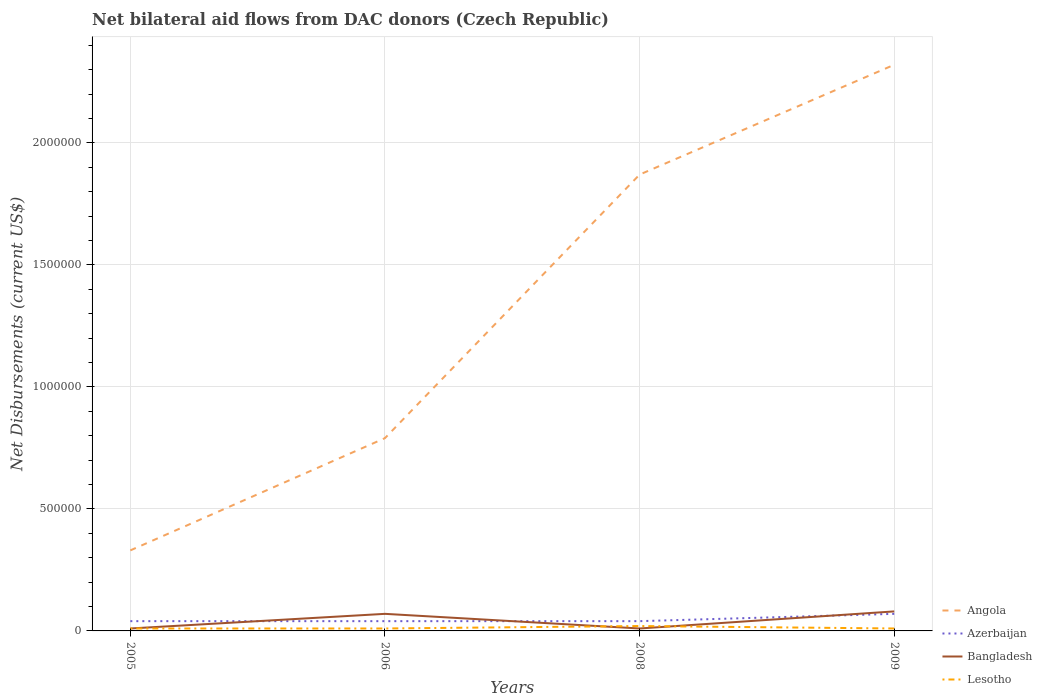How many different coloured lines are there?
Offer a very short reply. 4. Is the number of lines equal to the number of legend labels?
Make the answer very short. Yes. Across all years, what is the maximum net bilateral aid flows in Lesotho?
Your response must be concise. 10000. What is the total net bilateral aid flows in Azerbaijan in the graph?
Make the answer very short. -3.00e+04. What is the difference between the highest and the second highest net bilateral aid flows in Bangladesh?
Your answer should be compact. 7.00e+04. What is the difference between the highest and the lowest net bilateral aid flows in Lesotho?
Your answer should be compact. 1. How many years are there in the graph?
Offer a very short reply. 4. What is the difference between two consecutive major ticks on the Y-axis?
Offer a terse response. 5.00e+05. Are the values on the major ticks of Y-axis written in scientific E-notation?
Make the answer very short. No. Does the graph contain any zero values?
Ensure brevity in your answer.  No. How many legend labels are there?
Provide a succinct answer. 4. How are the legend labels stacked?
Ensure brevity in your answer.  Vertical. What is the title of the graph?
Ensure brevity in your answer.  Net bilateral aid flows from DAC donors (Czech Republic). Does "Channel Islands" appear as one of the legend labels in the graph?
Your answer should be very brief. No. What is the label or title of the Y-axis?
Give a very brief answer. Net Disbursements (current US$). What is the Net Disbursements (current US$) in Angola in 2005?
Make the answer very short. 3.30e+05. What is the Net Disbursements (current US$) in Azerbaijan in 2005?
Your response must be concise. 4.00e+04. What is the Net Disbursements (current US$) of Angola in 2006?
Provide a succinct answer. 7.90e+05. What is the Net Disbursements (current US$) in Lesotho in 2006?
Give a very brief answer. 10000. What is the Net Disbursements (current US$) in Angola in 2008?
Provide a short and direct response. 1.87e+06. What is the Net Disbursements (current US$) of Azerbaijan in 2008?
Your response must be concise. 4.00e+04. What is the Net Disbursements (current US$) of Bangladesh in 2008?
Provide a short and direct response. 10000. What is the Net Disbursements (current US$) in Lesotho in 2008?
Your answer should be compact. 2.00e+04. What is the Net Disbursements (current US$) in Angola in 2009?
Provide a succinct answer. 2.32e+06. What is the Net Disbursements (current US$) in Bangladesh in 2009?
Keep it short and to the point. 8.00e+04. What is the Net Disbursements (current US$) in Lesotho in 2009?
Make the answer very short. 10000. Across all years, what is the maximum Net Disbursements (current US$) of Angola?
Provide a short and direct response. 2.32e+06. Across all years, what is the maximum Net Disbursements (current US$) in Azerbaijan?
Provide a succinct answer. 7.00e+04. Across all years, what is the minimum Net Disbursements (current US$) of Angola?
Your answer should be very brief. 3.30e+05. Across all years, what is the minimum Net Disbursements (current US$) of Bangladesh?
Your answer should be very brief. 10000. Across all years, what is the minimum Net Disbursements (current US$) in Lesotho?
Offer a terse response. 10000. What is the total Net Disbursements (current US$) of Angola in the graph?
Keep it short and to the point. 5.31e+06. What is the difference between the Net Disbursements (current US$) of Angola in 2005 and that in 2006?
Ensure brevity in your answer.  -4.60e+05. What is the difference between the Net Disbursements (current US$) in Bangladesh in 2005 and that in 2006?
Your answer should be compact. -6.00e+04. What is the difference between the Net Disbursements (current US$) in Angola in 2005 and that in 2008?
Make the answer very short. -1.54e+06. What is the difference between the Net Disbursements (current US$) of Azerbaijan in 2005 and that in 2008?
Your response must be concise. 0. What is the difference between the Net Disbursements (current US$) of Bangladesh in 2005 and that in 2008?
Provide a succinct answer. 0. What is the difference between the Net Disbursements (current US$) in Lesotho in 2005 and that in 2008?
Your answer should be very brief. -10000. What is the difference between the Net Disbursements (current US$) in Angola in 2005 and that in 2009?
Offer a very short reply. -1.99e+06. What is the difference between the Net Disbursements (current US$) in Angola in 2006 and that in 2008?
Your answer should be very brief. -1.08e+06. What is the difference between the Net Disbursements (current US$) of Lesotho in 2006 and that in 2008?
Ensure brevity in your answer.  -10000. What is the difference between the Net Disbursements (current US$) in Angola in 2006 and that in 2009?
Your answer should be compact. -1.53e+06. What is the difference between the Net Disbursements (current US$) in Azerbaijan in 2006 and that in 2009?
Offer a very short reply. -3.00e+04. What is the difference between the Net Disbursements (current US$) of Lesotho in 2006 and that in 2009?
Keep it short and to the point. 0. What is the difference between the Net Disbursements (current US$) in Angola in 2008 and that in 2009?
Offer a very short reply. -4.50e+05. What is the difference between the Net Disbursements (current US$) in Angola in 2005 and the Net Disbursements (current US$) in Lesotho in 2006?
Your response must be concise. 3.20e+05. What is the difference between the Net Disbursements (current US$) of Azerbaijan in 2005 and the Net Disbursements (current US$) of Lesotho in 2006?
Offer a terse response. 3.00e+04. What is the difference between the Net Disbursements (current US$) of Bangladesh in 2005 and the Net Disbursements (current US$) of Lesotho in 2006?
Your response must be concise. 0. What is the difference between the Net Disbursements (current US$) of Azerbaijan in 2005 and the Net Disbursements (current US$) of Lesotho in 2008?
Your response must be concise. 2.00e+04. What is the difference between the Net Disbursements (current US$) in Angola in 2005 and the Net Disbursements (current US$) in Azerbaijan in 2009?
Provide a short and direct response. 2.60e+05. What is the difference between the Net Disbursements (current US$) of Azerbaijan in 2005 and the Net Disbursements (current US$) of Lesotho in 2009?
Provide a short and direct response. 3.00e+04. What is the difference between the Net Disbursements (current US$) in Bangladesh in 2005 and the Net Disbursements (current US$) in Lesotho in 2009?
Provide a succinct answer. 0. What is the difference between the Net Disbursements (current US$) of Angola in 2006 and the Net Disbursements (current US$) of Azerbaijan in 2008?
Offer a terse response. 7.50e+05. What is the difference between the Net Disbursements (current US$) of Angola in 2006 and the Net Disbursements (current US$) of Bangladesh in 2008?
Your answer should be very brief. 7.80e+05. What is the difference between the Net Disbursements (current US$) of Angola in 2006 and the Net Disbursements (current US$) of Lesotho in 2008?
Offer a terse response. 7.70e+05. What is the difference between the Net Disbursements (current US$) of Azerbaijan in 2006 and the Net Disbursements (current US$) of Bangladesh in 2008?
Make the answer very short. 3.00e+04. What is the difference between the Net Disbursements (current US$) in Bangladesh in 2006 and the Net Disbursements (current US$) in Lesotho in 2008?
Provide a short and direct response. 5.00e+04. What is the difference between the Net Disbursements (current US$) of Angola in 2006 and the Net Disbursements (current US$) of Azerbaijan in 2009?
Give a very brief answer. 7.20e+05. What is the difference between the Net Disbursements (current US$) in Angola in 2006 and the Net Disbursements (current US$) in Bangladesh in 2009?
Make the answer very short. 7.10e+05. What is the difference between the Net Disbursements (current US$) in Angola in 2006 and the Net Disbursements (current US$) in Lesotho in 2009?
Make the answer very short. 7.80e+05. What is the difference between the Net Disbursements (current US$) of Azerbaijan in 2006 and the Net Disbursements (current US$) of Bangladesh in 2009?
Make the answer very short. -4.00e+04. What is the difference between the Net Disbursements (current US$) of Azerbaijan in 2006 and the Net Disbursements (current US$) of Lesotho in 2009?
Provide a short and direct response. 3.00e+04. What is the difference between the Net Disbursements (current US$) of Bangladesh in 2006 and the Net Disbursements (current US$) of Lesotho in 2009?
Your answer should be very brief. 6.00e+04. What is the difference between the Net Disbursements (current US$) in Angola in 2008 and the Net Disbursements (current US$) in Azerbaijan in 2009?
Offer a terse response. 1.80e+06. What is the difference between the Net Disbursements (current US$) in Angola in 2008 and the Net Disbursements (current US$) in Bangladesh in 2009?
Offer a very short reply. 1.79e+06. What is the difference between the Net Disbursements (current US$) in Angola in 2008 and the Net Disbursements (current US$) in Lesotho in 2009?
Provide a short and direct response. 1.86e+06. What is the difference between the Net Disbursements (current US$) in Azerbaijan in 2008 and the Net Disbursements (current US$) in Bangladesh in 2009?
Your answer should be very brief. -4.00e+04. What is the difference between the Net Disbursements (current US$) in Azerbaijan in 2008 and the Net Disbursements (current US$) in Lesotho in 2009?
Give a very brief answer. 3.00e+04. What is the average Net Disbursements (current US$) of Angola per year?
Offer a terse response. 1.33e+06. What is the average Net Disbursements (current US$) in Azerbaijan per year?
Offer a very short reply. 4.75e+04. What is the average Net Disbursements (current US$) of Bangladesh per year?
Your answer should be very brief. 4.25e+04. What is the average Net Disbursements (current US$) of Lesotho per year?
Give a very brief answer. 1.25e+04. In the year 2005, what is the difference between the Net Disbursements (current US$) in Angola and Net Disbursements (current US$) in Bangladesh?
Ensure brevity in your answer.  3.20e+05. In the year 2005, what is the difference between the Net Disbursements (current US$) in Azerbaijan and Net Disbursements (current US$) in Bangladesh?
Provide a short and direct response. 3.00e+04. In the year 2005, what is the difference between the Net Disbursements (current US$) in Azerbaijan and Net Disbursements (current US$) in Lesotho?
Your answer should be compact. 3.00e+04. In the year 2006, what is the difference between the Net Disbursements (current US$) of Angola and Net Disbursements (current US$) of Azerbaijan?
Your answer should be very brief. 7.50e+05. In the year 2006, what is the difference between the Net Disbursements (current US$) in Angola and Net Disbursements (current US$) in Bangladesh?
Your answer should be compact. 7.20e+05. In the year 2006, what is the difference between the Net Disbursements (current US$) in Angola and Net Disbursements (current US$) in Lesotho?
Your answer should be very brief. 7.80e+05. In the year 2008, what is the difference between the Net Disbursements (current US$) of Angola and Net Disbursements (current US$) of Azerbaijan?
Give a very brief answer. 1.83e+06. In the year 2008, what is the difference between the Net Disbursements (current US$) of Angola and Net Disbursements (current US$) of Bangladesh?
Make the answer very short. 1.86e+06. In the year 2008, what is the difference between the Net Disbursements (current US$) of Angola and Net Disbursements (current US$) of Lesotho?
Offer a terse response. 1.85e+06. In the year 2008, what is the difference between the Net Disbursements (current US$) in Azerbaijan and Net Disbursements (current US$) in Bangladesh?
Your response must be concise. 3.00e+04. In the year 2008, what is the difference between the Net Disbursements (current US$) in Azerbaijan and Net Disbursements (current US$) in Lesotho?
Provide a short and direct response. 2.00e+04. In the year 2008, what is the difference between the Net Disbursements (current US$) of Bangladesh and Net Disbursements (current US$) of Lesotho?
Ensure brevity in your answer.  -10000. In the year 2009, what is the difference between the Net Disbursements (current US$) of Angola and Net Disbursements (current US$) of Azerbaijan?
Your response must be concise. 2.25e+06. In the year 2009, what is the difference between the Net Disbursements (current US$) in Angola and Net Disbursements (current US$) in Bangladesh?
Give a very brief answer. 2.24e+06. In the year 2009, what is the difference between the Net Disbursements (current US$) in Angola and Net Disbursements (current US$) in Lesotho?
Offer a very short reply. 2.31e+06. In the year 2009, what is the difference between the Net Disbursements (current US$) in Bangladesh and Net Disbursements (current US$) in Lesotho?
Offer a very short reply. 7.00e+04. What is the ratio of the Net Disbursements (current US$) in Angola in 2005 to that in 2006?
Give a very brief answer. 0.42. What is the ratio of the Net Disbursements (current US$) in Azerbaijan in 2005 to that in 2006?
Provide a succinct answer. 1. What is the ratio of the Net Disbursements (current US$) in Bangladesh in 2005 to that in 2006?
Ensure brevity in your answer.  0.14. What is the ratio of the Net Disbursements (current US$) of Angola in 2005 to that in 2008?
Your response must be concise. 0.18. What is the ratio of the Net Disbursements (current US$) in Angola in 2005 to that in 2009?
Offer a very short reply. 0.14. What is the ratio of the Net Disbursements (current US$) in Angola in 2006 to that in 2008?
Give a very brief answer. 0.42. What is the ratio of the Net Disbursements (current US$) of Angola in 2006 to that in 2009?
Give a very brief answer. 0.34. What is the ratio of the Net Disbursements (current US$) in Azerbaijan in 2006 to that in 2009?
Offer a terse response. 0.57. What is the ratio of the Net Disbursements (current US$) of Lesotho in 2006 to that in 2009?
Your response must be concise. 1. What is the ratio of the Net Disbursements (current US$) of Angola in 2008 to that in 2009?
Ensure brevity in your answer.  0.81. What is the ratio of the Net Disbursements (current US$) in Lesotho in 2008 to that in 2009?
Your answer should be very brief. 2. What is the difference between the highest and the second highest Net Disbursements (current US$) of Azerbaijan?
Offer a very short reply. 3.00e+04. What is the difference between the highest and the second highest Net Disbursements (current US$) in Bangladesh?
Keep it short and to the point. 10000. What is the difference between the highest and the lowest Net Disbursements (current US$) of Angola?
Make the answer very short. 1.99e+06. What is the difference between the highest and the lowest Net Disbursements (current US$) of Azerbaijan?
Your answer should be very brief. 3.00e+04. 